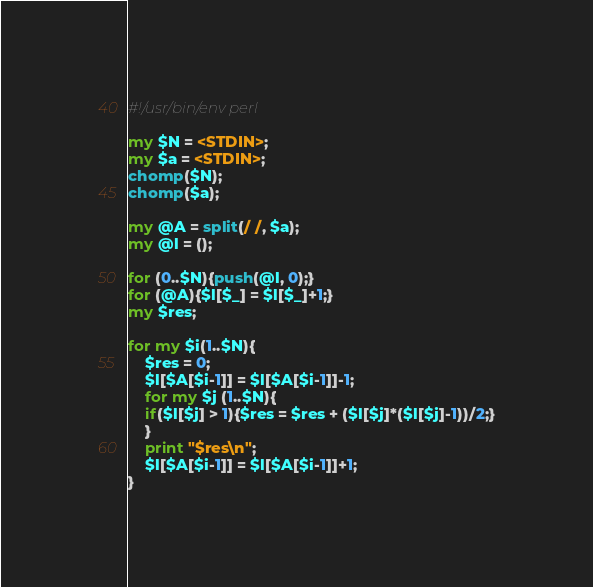<code> <loc_0><loc_0><loc_500><loc_500><_Perl_>#!/usr/bin/env perl

my $N = <STDIN>;
my $a = <STDIN>;
chomp($N);
chomp($a);

my @A = split(/ /, $a);
my @l = ();

for (0..$N){push(@l, 0);}
for (@A){$l[$_] = $l[$_]+1;}
my $res;

for my $i(1..$N){
    $res = 0;
    $l[$A[$i-1]] = $l[$A[$i-1]]-1;
    for my $j (1..$N){
	if($l[$j] > 1){$res = $res + ($l[$j]*($l[$j]-1))/2;}
    }
    print "$res\n";
    $l[$A[$i-1]] = $l[$A[$i-1]]+1;
}
</code> 